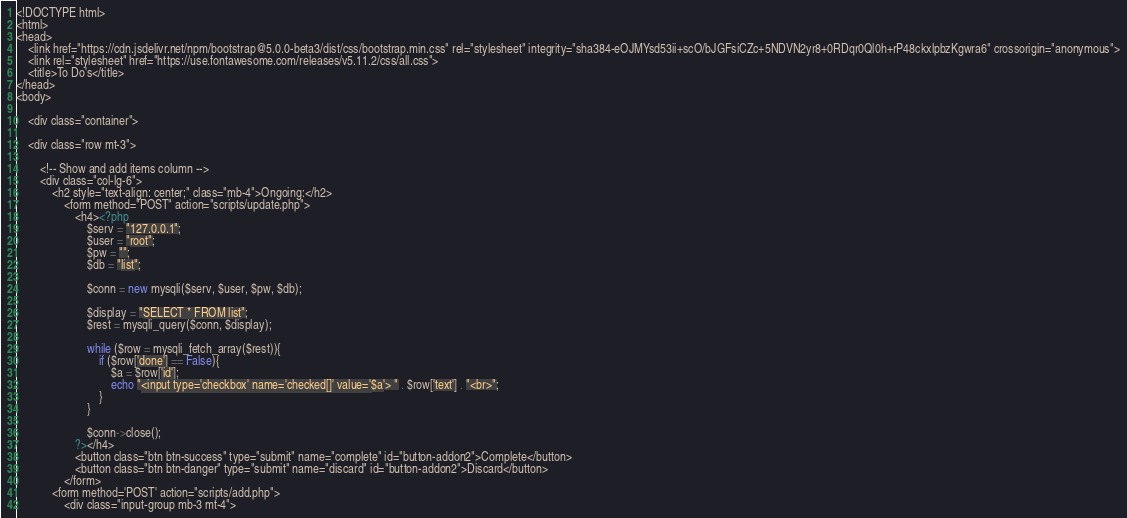Convert code to text. <code><loc_0><loc_0><loc_500><loc_500><_PHP_><!DOCTYPE html>
<html>
<head>
	<link href="https://cdn.jsdelivr.net/npm/bootstrap@5.0.0-beta3/dist/css/bootstrap.min.css" rel="stylesheet" integrity="sha384-eOJMYsd53ii+scO/bJGFsiCZc+5NDVN2yr8+0RDqr0Ql0h+rP48ckxlpbzKgwra6" crossorigin="anonymous">
	<link rel="stylesheet" href="https://use.fontawesome.com/releases/v5.11.2/css/all.css">
	<title>To Do's</title>
</head>
<body>

	<div class="container">

    <div class="row mt-3">

        <!-- Show and add items column -->
        <div class="col-lg-6">
            <h2 style="text-align: center;" class="mb-4">Ongoing:</h2>
                <form method="POST" action="scripts/update.php">
                    <h4><?php 
                        $serv = "127.0.0.1";
                        $user = "root";
                        $pw = "";
                        $db = "list";

                        $conn = new mysqli($serv, $user, $pw, $db);

                        $display = "SELECT * FROM list";
                        $rest = mysqli_query($conn, $display);

                        while ($row = mysqli_fetch_array($rest)){  
                            if ($row['done'] == False){
                                $a = $row['id'];
                                echo "<input type='checkbox' name='checked[]' value='$a'> " . $row['text'] . "<br>";
                            }
                        }

                        $conn->close();
                    ?></h4>
                    <button class="btn btn-success" type="submit" name="complete" id="button-addon2">Complete</button>
                    <button class="btn btn-danger" type="submit" name="discard" id="button-addon2">Discard</button>
                </form>
            <form method='POST' action="scripts/add.php">
                <div class="input-group mb-3 mt-4"></code> 